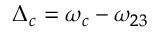Convert formula to latex. <formula><loc_0><loc_0><loc_500><loc_500>{ \Delta _ { c } } = { \omega _ { c } } - { \omega _ { 2 3 } }</formula> 